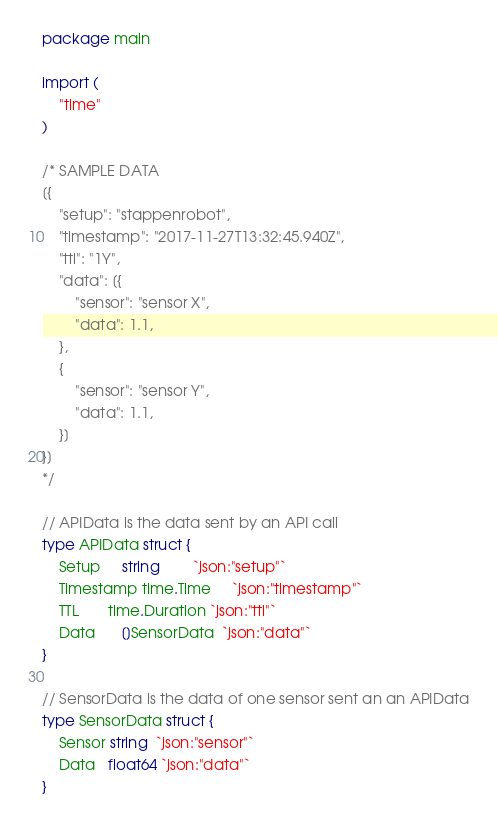Convert code to text. <code><loc_0><loc_0><loc_500><loc_500><_Go_>package main

import (
	"time"
)

/* SAMPLE DATA
[{
    "setup": "stappenrobot",
    "timestamp": "2017-11-27T13:32:45.940Z",
    "ttl": "1Y",
    "data": [{
        "sensor": "sensor X",
        "data": 1.1,
    },
    {
        "sensor": "sensor Y",
        "data": 1.1,
    }]
}]
*/

// APIData is the data sent by an API call
type APIData struct {
	Setup     string        `json:"setup"`
	Timestamp time.Time     `json:"timestamp"`
	TTL       time.Duration `json:"ttl"`
	Data      []SensorData  `json:"data"`
}

// SensorData is the data of one sensor sent an an APIData
type SensorData struct {
	Sensor string  `json:"sensor"`
	Data   float64 `json:"data"`
}
</code> 